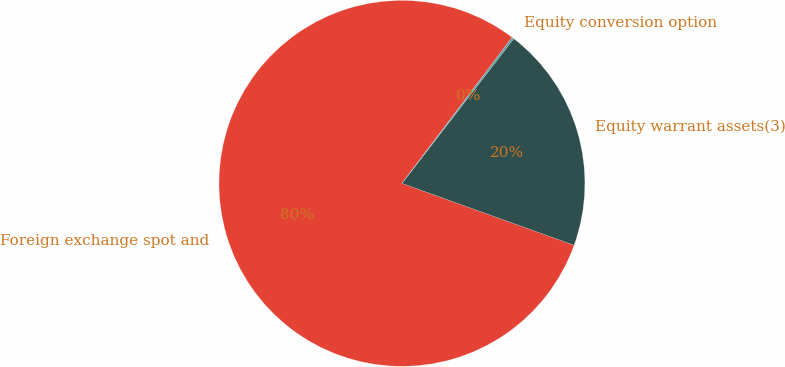<chart> <loc_0><loc_0><loc_500><loc_500><pie_chart><fcel>Foreign exchange spot and<fcel>Equity warrant assets(3)<fcel>Equity conversion option<nl><fcel>79.79%<fcel>20.02%<fcel>0.18%<nl></chart> 